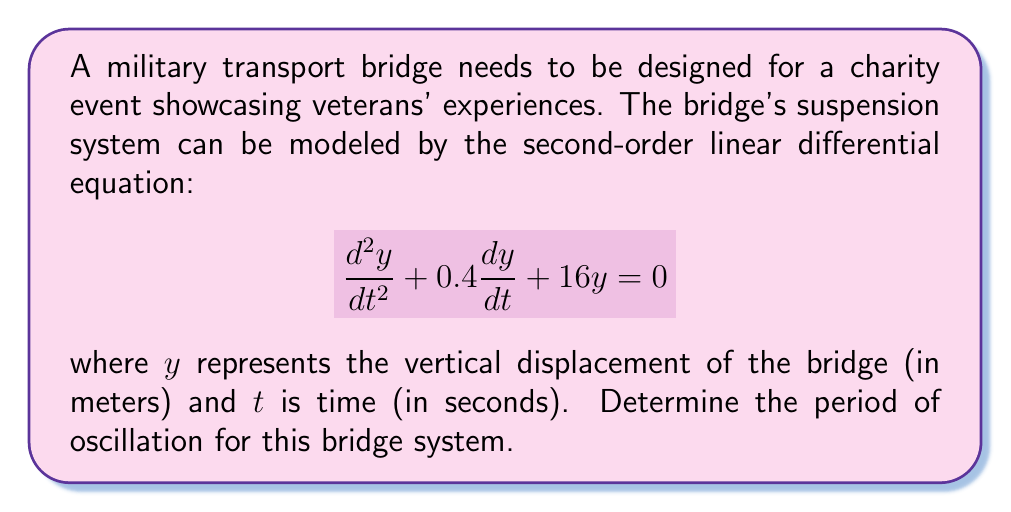Can you solve this math problem? To find the period of oscillation, we need to follow these steps:

1) The general form of a second-order linear differential equation is:

   $$\frac{d^2y}{dt^2} + 2\zeta\omega_n\frac{dy}{dt} + \omega_n^2y = 0$$

   where $\zeta$ is the damping ratio and $\omega_n$ is the natural frequency.

2) Comparing our equation to the general form, we can identify:

   $2\zeta\omega_n = 0.4$
   $\omega_n^2 = 16$

3) From $\omega_n^2 = 16$, we can deduce:

   $\omega_n = \sqrt{16} = 4$ rad/s

4) The damped natural frequency $\omega_d$ is given by:

   $$\omega_d = \omega_n\sqrt{1-\zeta^2}$$

5) To find $\zeta$, we use:

   $2\zeta\omega_n = 0.4$
   $2\zeta(4) = 0.4$
   $\zeta = 0.05$

6) Now we can calculate $\omega_d$:

   $$\omega_d = 4\sqrt{1-0.05^2} \approx 3.9899$$ rad/s

7) The period of oscillation $T$ is related to the frequency by:

   $$T = \frac{2\pi}{\omega_d}$$

8) Substituting our value for $\omega_d$:

   $$T = \frac{2\pi}{3.9899} \approx 1.5748$$ seconds
Answer: The period of oscillation for the bridge system is approximately 1.5748 seconds. 